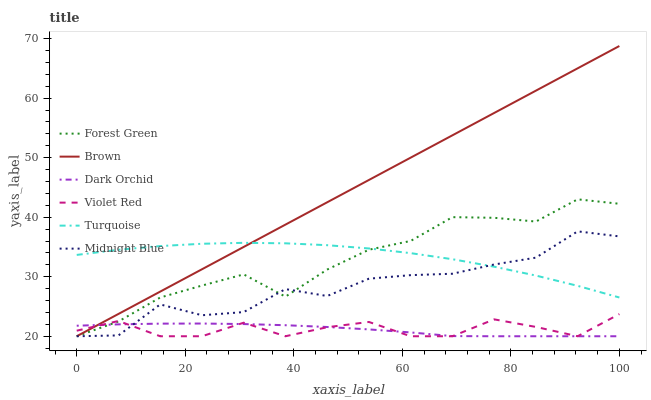Does Turquoise have the minimum area under the curve?
Answer yes or no. No. Does Turquoise have the maximum area under the curve?
Answer yes or no. No. Is Turquoise the smoothest?
Answer yes or no. No. Is Turquoise the roughest?
Answer yes or no. No. Does Turquoise have the lowest value?
Answer yes or no. No. Does Turquoise have the highest value?
Answer yes or no. No. Is Violet Red less than Turquoise?
Answer yes or no. Yes. Is Turquoise greater than Violet Red?
Answer yes or no. Yes. Does Violet Red intersect Turquoise?
Answer yes or no. No. 